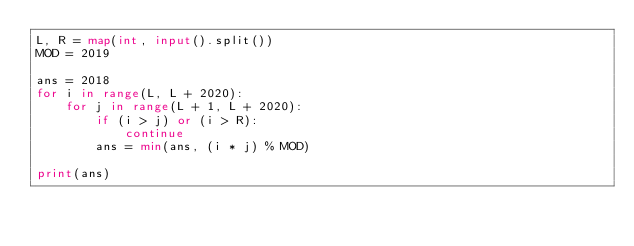<code> <loc_0><loc_0><loc_500><loc_500><_Python_>L, R = map(int, input().split())
MOD = 2019

ans = 2018
for i in range(L, L + 2020):
    for j in range(L + 1, L + 2020):
        if (i > j) or (i > R):
            continue
        ans = min(ans, (i * j) % MOD)

print(ans)
</code> 